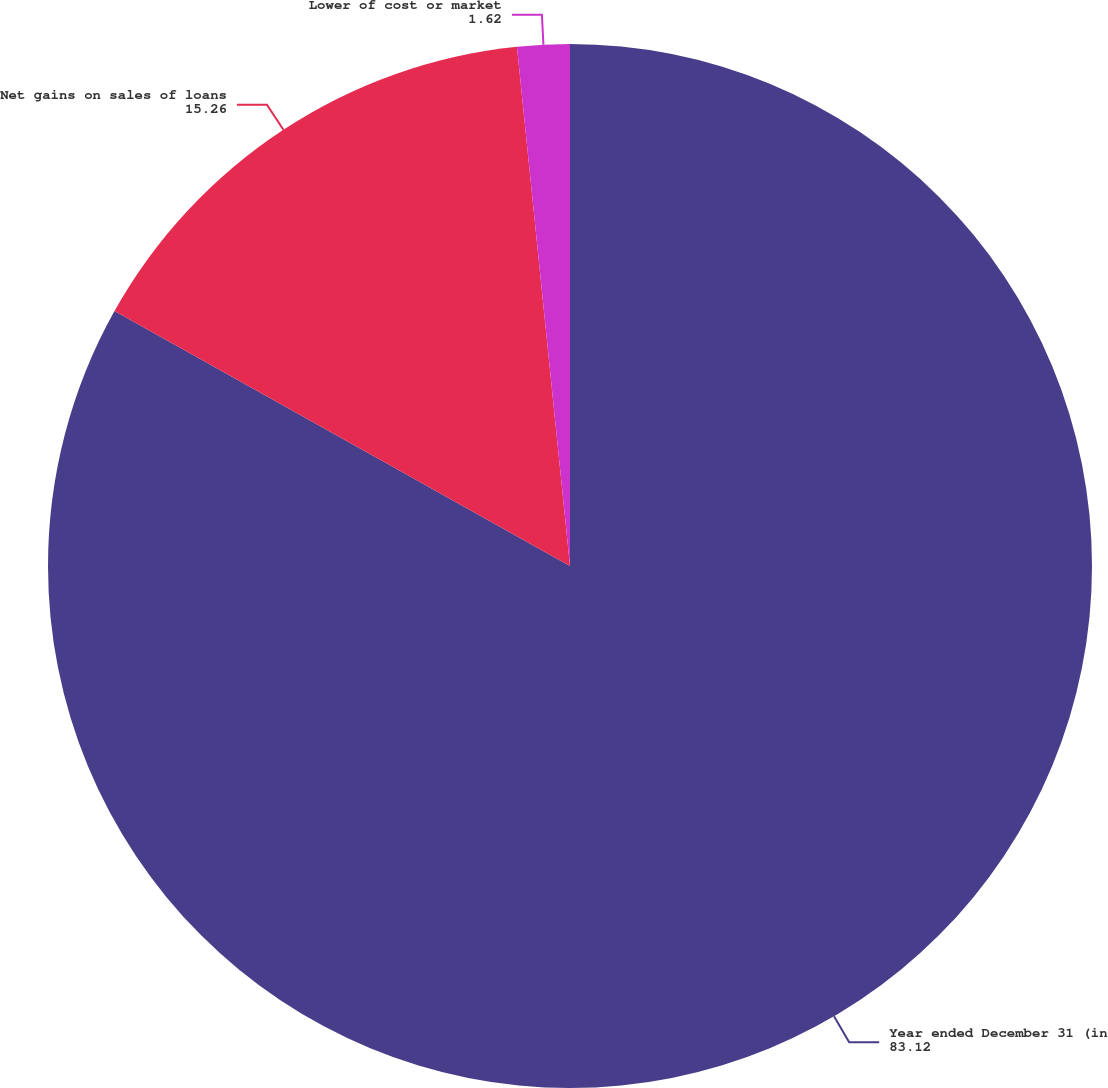Convert chart to OTSL. <chart><loc_0><loc_0><loc_500><loc_500><pie_chart><fcel>Year ended December 31 (in<fcel>Net gains on sales of loans<fcel>Lower of cost or market<nl><fcel>83.12%<fcel>15.26%<fcel>1.62%<nl></chart> 